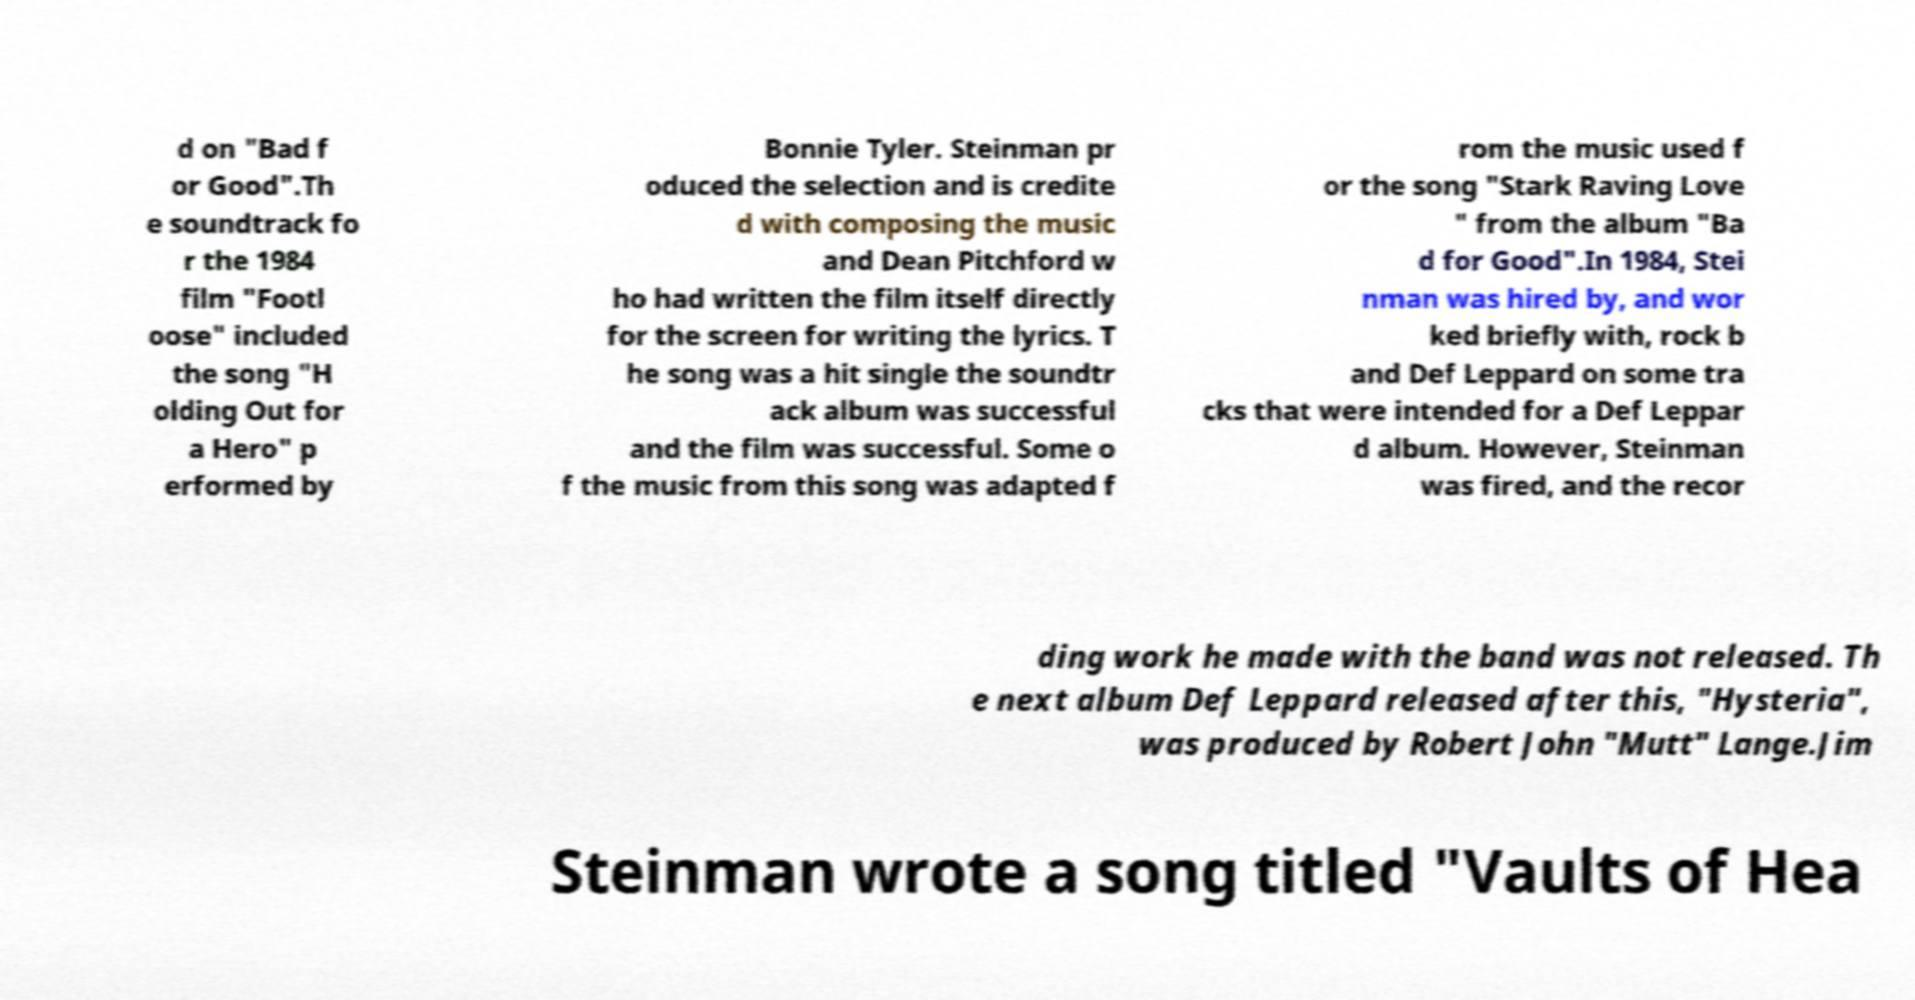Can you read and provide the text displayed in the image?This photo seems to have some interesting text. Can you extract and type it out for me? d on "Bad f or Good".Th e soundtrack fo r the 1984 film "Footl oose" included the song "H olding Out for a Hero" p erformed by Bonnie Tyler. Steinman pr oduced the selection and is credite d with composing the music and Dean Pitchford w ho had written the film itself directly for the screen for writing the lyrics. T he song was a hit single the soundtr ack album was successful and the film was successful. Some o f the music from this song was adapted f rom the music used f or the song "Stark Raving Love " from the album "Ba d for Good".In 1984, Stei nman was hired by, and wor ked briefly with, rock b and Def Leppard on some tra cks that were intended for a Def Leppar d album. However, Steinman was fired, and the recor ding work he made with the band was not released. Th e next album Def Leppard released after this, "Hysteria", was produced by Robert John "Mutt" Lange.Jim Steinman wrote a song titled "Vaults of Hea 